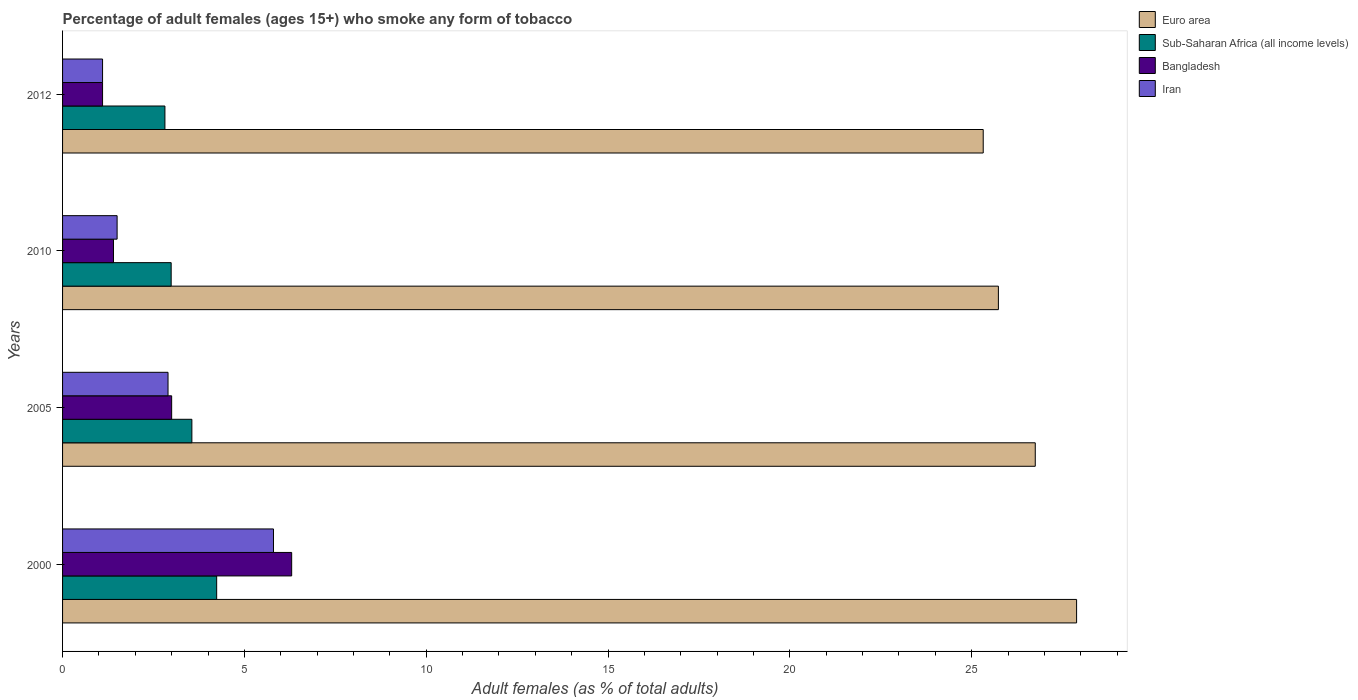Are the number of bars per tick equal to the number of legend labels?
Keep it short and to the point. Yes. Are the number of bars on each tick of the Y-axis equal?
Make the answer very short. Yes. In how many cases, is the number of bars for a given year not equal to the number of legend labels?
Provide a succinct answer. 0. What is the percentage of adult females who smoke in Sub-Saharan Africa (all income levels) in 2000?
Your answer should be very brief. 4.24. Across all years, what is the maximum percentage of adult females who smoke in Bangladesh?
Provide a succinct answer. 6.3. Across all years, what is the minimum percentage of adult females who smoke in Bangladesh?
Ensure brevity in your answer.  1.1. In which year was the percentage of adult females who smoke in Euro area minimum?
Your response must be concise. 2012. What is the total percentage of adult females who smoke in Bangladesh in the graph?
Keep it short and to the point. 11.8. What is the difference between the percentage of adult females who smoke in Iran in 2005 and that in 2010?
Your response must be concise. 1.4. What is the difference between the percentage of adult females who smoke in Sub-Saharan Africa (all income levels) in 2010 and the percentage of adult females who smoke in Euro area in 2005?
Provide a short and direct response. -23.76. What is the average percentage of adult females who smoke in Euro area per year?
Offer a terse response. 26.42. In the year 2012, what is the difference between the percentage of adult females who smoke in Iran and percentage of adult females who smoke in Euro area?
Give a very brief answer. -24.22. What is the ratio of the percentage of adult females who smoke in Bangladesh in 2010 to that in 2012?
Provide a succinct answer. 1.27. Is the difference between the percentage of adult females who smoke in Iran in 2010 and 2012 greater than the difference between the percentage of adult females who smoke in Euro area in 2010 and 2012?
Keep it short and to the point. No. What is the difference between the highest and the lowest percentage of adult females who smoke in Bangladesh?
Keep it short and to the point. 5.2. In how many years, is the percentage of adult females who smoke in Iran greater than the average percentage of adult females who smoke in Iran taken over all years?
Offer a terse response. 2. Is the sum of the percentage of adult females who smoke in Euro area in 2000 and 2005 greater than the maximum percentage of adult females who smoke in Bangladesh across all years?
Give a very brief answer. Yes. What does the 1st bar from the top in 2010 represents?
Your answer should be compact. Iran. What does the 2nd bar from the bottom in 2012 represents?
Provide a short and direct response. Sub-Saharan Africa (all income levels). What is the difference between two consecutive major ticks on the X-axis?
Your answer should be very brief. 5. Does the graph contain any zero values?
Provide a succinct answer. No. What is the title of the graph?
Offer a terse response. Percentage of adult females (ages 15+) who smoke any form of tobacco. What is the label or title of the X-axis?
Your answer should be compact. Adult females (as % of total adults). What is the label or title of the Y-axis?
Ensure brevity in your answer.  Years. What is the Adult females (as % of total adults) of Euro area in 2000?
Your answer should be compact. 27.88. What is the Adult females (as % of total adults) of Sub-Saharan Africa (all income levels) in 2000?
Offer a very short reply. 4.24. What is the Adult females (as % of total adults) of Bangladesh in 2000?
Your answer should be compact. 6.3. What is the Adult females (as % of total adults) in Iran in 2000?
Provide a succinct answer. 5.8. What is the Adult females (as % of total adults) in Euro area in 2005?
Provide a short and direct response. 26.75. What is the Adult females (as % of total adults) in Sub-Saharan Africa (all income levels) in 2005?
Offer a terse response. 3.56. What is the Adult females (as % of total adults) of Iran in 2005?
Keep it short and to the point. 2.9. What is the Adult females (as % of total adults) of Euro area in 2010?
Your response must be concise. 25.73. What is the Adult females (as % of total adults) of Sub-Saharan Africa (all income levels) in 2010?
Your answer should be compact. 2.99. What is the Adult females (as % of total adults) in Iran in 2010?
Your answer should be compact. 1.5. What is the Adult females (as % of total adults) of Euro area in 2012?
Your answer should be compact. 25.32. What is the Adult females (as % of total adults) in Sub-Saharan Africa (all income levels) in 2012?
Your answer should be very brief. 2.81. Across all years, what is the maximum Adult females (as % of total adults) of Euro area?
Ensure brevity in your answer.  27.88. Across all years, what is the maximum Adult females (as % of total adults) of Sub-Saharan Africa (all income levels)?
Offer a terse response. 4.24. Across all years, what is the maximum Adult females (as % of total adults) in Iran?
Provide a succinct answer. 5.8. Across all years, what is the minimum Adult females (as % of total adults) in Euro area?
Provide a succinct answer. 25.32. Across all years, what is the minimum Adult females (as % of total adults) in Sub-Saharan Africa (all income levels)?
Keep it short and to the point. 2.81. Across all years, what is the minimum Adult females (as % of total adults) in Bangladesh?
Your answer should be compact. 1.1. Across all years, what is the minimum Adult females (as % of total adults) in Iran?
Make the answer very short. 1.1. What is the total Adult females (as % of total adults) in Euro area in the graph?
Your answer should be very brief. 105.68. What is the total Adult females (as % of total adults) in Sub-Saharan Africa (all income levels) in the graph?
Keep it short and to the point. 13.59. What is the total Adult females (as % of total adults) in Bangladesh in the graph?
Ensure brevity in your answer.  11.8. What is the total Adult females (as % of total adults) in Iran in the graph?
Provide a succinct answer. 11.3. What is the difference between the Adult females (as % of total adults) in Euro area in 2000 and that in 2005?
Provide a succinct answer. 1.14. What is the difference between the Adult females (as % of total adults) in Sub-Saharan Africa (all income levels) in 2000 and that in 2005?
Offer a very short reply. 0.68. What is the difference between the Adult females (as % of total adults) in Iran in 2000 and that in 2005?
Your answer should be very brief. 2.9. What is the difference between the Adult females (as % of total adults) of Euro area in 2000 and that in 2010?
Make the answer very short. 2.15. What is the difference between the Adult females (as % of total adults) in Sub-Saharan Africa (all income levels) in 2000 and that in 2010?
Give a very brief answer. 1.25. What is the difference between the Adult females (as % of total adults) in Iran in 2000 and that in 2010?
Provide a succinct answer. 4.3. What is the difference between the Adult females (as % of total adults) in Euro area in 2000 and that in 2012?
Your answer should be very brief. 2.57. What is the difference between the Adult females (as % of total adults) of Sub-Saharan Africa (all income levels) in 2000 and that in 2012?
Offer a terse response. 1.42. What is the difference between the Adult females (as % of total adults) in Euro area in 2005 and that in 2010?
Your response must be concise. 1.01. What is the difference between the Adult females (as % of total adults) in Sub-Saharan Africa (all income levels) in 2005 and that in 2010?
Provide a short and direct response. 0.57. What is the difference between the Adult females (as % of total adults) of Iran in 2005 and that in 2010?
Your answer should be compact. 1.4. What is the difference between the Adult females (as % of total adults) of Euro area in 2005 and that in 2012?
Provide a succinct answer. 1.43. What is the difference between the Adult females (as % of total adults) in Sub-Saharan Africa (all income levels) in 2005 and that in 2012?
Offer a very short reply. 0.74. What is the difference between the Adult females (as % of total adults) in Iran in 2005 and that in 2012?
Offer a terse response. 1.8. What is the difference between the Adult females (as % of total adults) in Euro area in 2010 and that in 2012?
Your answer should be compact. 0.42. What is the difference between the Adult females (as % of total adults) in Sub-Saharan Africa (all income levels) in 2010 and that in 2012?
Give a very brief answer. 0.17. What is the difference between the Adult females (as % of total adults) of Bangladesh in 2010 and that in 2012?
Offer a terse response. 0.3. What is the difference between the Adult females (as % of total adults) of Iran in 2010 and that in 2012?
Your answer should be compact. 0.4. What is the difference between the Adult females (as % of total adults) of Euro area in 2000 and the Adult females (as % of total adults) of Sub-Saharan Africa (all income levels) in 2005?
Keep it short and to the point. 24.33. What is the difference between the Adult females (as % of total adults) of Euro area in 2000 and the Adult females (as % of total adults) of Bangladesh in 2005?
Provide a short and direct response. 24.88. What is the difference between the Adult females (as % of total adults) of Euro area in 2000 and the Adult females (as % of total adults) of Iran in 2005?
Offer a terse response. 24.98. What is the difference between the Adult females (as % of total adults) in Sub-Saharan Africa (all income levels) in 2000 and the Adult females (as % of total adults) in Bangladesh in 2005?
Provide a succinct answer. 1.24. What is the difference between the Adult females (as % of total adults) of Sub-Saharan Africa (all income levels) in 2000 and the Adult females (as % of total adults) of Iran in 2005?
Offer a terse response. 1.34. What is the difference between the Adult females (as % of total adults) in Bangladesh in 2000 and the Adult females (as % of total adults) in Iran in 2005?
Offer a terse response. 3.4. What is the difference between the Adult females (as % of total adults) of Euro area in 2000 and the Adult females (as % of total adults) of Sub-Saharan Africa (all income levels) in 2010?
Make the answer very short. 24.9. What is the difference between the Adult females (as % of total adults) in Euro area in 2000 and the Adult females (as % of total adults) in Bangladesh in 2010?
Provide a succinct answer. 26.48. What is the difference between the Adult females (as % of total adults) of Euro area in 2000 and the Adult females (as % of total adults) of Iran in 2010?
Make the answer very short. 26.38. What is the difference between the Adult females (as % of total adults) in Sub-Saharan Africa (all income levels) in 2000 and the Adult females (as % of total adults) in Bangladesh in 2010?
Offer a very short reply. 2.84. What is the difference between the Adult females (as % of total adults) of Sub-Saharan Africa (all income levels) in 2000 and the Adult females (as % of total adults) of Iran in 2010?
Give a very brief answer. 2.74. What is the difference between the Adult females (as % of total adults) of Euro area in 2000 and the Adult females (as % of total adults) of Sub-Saharan Africa (all income levels) in 2012?
Your answer should be compact. 25.07. What is the difference between the Adult females (as % of total adults) of Euro area in 2000 and the Adult females (as % of total adults) of Bangladesh in 2012?
Offer a very short reply. 26.78. What is the difference between the Adult females (as % of total adults) in Euro area in 2000 and the Adult females (as % of total adults) in Iran in 2012?
Ensure brevity in your answer.  26.78. What is the difference between the Adult females (as % of total adults) in Sub-Saharan Africa (all income levels) in 2000 and the Adult females (as % of total adults) in Bangladesh in 2012?
Provide a short and direct response. 3.14. What is the difference between the Adult females (as % of total adults) in Sub-Saharan Africa (all income levels) in 2000 and the Adult females (as % of total adults) in Iran in 2012?
Offer a very short reply. 3.14. What is the difference between the Adult females (as % of total adults) of Euro area in 2005 and the Adult females (as % of total adults) of Sub-Saharan Africa (all income levels) in 2010?
Your answer should be very brief. 23.76. What is the difference between the Adult females (as % of total adults) in Euro area in 2005 and the Adult females (as % of total adults) in Bangladesh in 2010?
Keep it short and to the point. 25.35. What is the difference between the Adult females (as % of total adults) of Euro area in 2005 and the Adult females (as % of total adults) of Iran in 2010?
Keep it short and to the point. 25.25. What is the difference between the Adult females (as % of total adults) in Sub-Saharan Africa (all income levels) in 2005 and the Adult females (as % of total adults) in Bangladesh in 2010?
Offer a terse response. 2.16. What is the difference between the Adult females (as % of total adults) of Sub-Saharan Africa (all income levels) in 2005 and the Adult females (as % of total adults) of Iran in 2010?
Your answer should be compact. 2.06. What is the difference between the Adult females (as % of total adults) in Bangladesh in 2005 and the Adult females (as % of total adults) in Iran in 2010?
Offer a terse response. 1.5. What is the difference between the Adult females (as % of total adults) of Euro area in 2005 and the Adult females (as % of total adults) of Sub-Saharan Africa (all income levels) in 2012?
Provide a short and direct response. 23.93. What is the difference between the Adult females (as % of total adults) of Euro area in 2005 and the Adult females (as % of total adults) of Bangladesh in 2012?
Your answer should be very brief. 25.65. What is the difference between the Adult females (as % of total adults) in Euro area in 2005 and the Adult females (as % of total adults) in Iran in 2012?
Offer a very short reply. 25.65. What is the difference between the Adult females (as % of total adults) in Sub-Saharan Africa (all income levels) in 2005 and the Adult females (as % of total adults) in Bangladesh in 2012?
Keep it short and to the point. 2.46. What is the difference between the Adult females (as % of total adults) in Sub-Saharan Africa (all income levels) in 2005 and the Adult females (as % of total adults) in Iran in 2012?
Your answer should be very brief. 2.46. What is the difference between the Adult females (as % of total adults) of Bangladesh in 2005 and the Adult females (as % of total adults) of Iran in 2012?
Your answer should be compact. 1.9. What is the difference between the Adult females (as % of total adults) of Euro area in 2010 and the Adult females (as % of total adults) of Sub-Saharan Africa (all income levels) in 2012?
Your answer should be compact. 22.92. What is the difference between the Adult females (as % of total adults) in Euro area in 2010 and the Adult females (as % of total adults) in Bangladesh in 2012?
Offer a terse response. 24.63. What is the difference between the Adult females (as % of total adults) of Euro area in 2010 and the Adult females (as % of total adults) of Iran in 2012?
Offer a very short reply. 24.63. What is the difference between the Adult females (as % of total adults) in Sub-Saharan Africa (all income levels) in 2010 and the Adult females (as % of total adults) in Bangladesh in 2012?
Provide a short and direct response. 1.89. What is the difference between the Adult females (as % of total adults) in Sub-Saharan Africa (all income levels) in 2010 and the Adult females (as % of total adults) in Iran in 2012?
Give a very brief answer. 1.89. What is the difference between the Adult females (as % of total adults) of Bangladesh in 2010 and the Adult females (as % of total adults) of Iran in 2012?
Provide a succinct answer. 0.3. What is the average Adult females (as % of total adults) of Euro area per year?
Offer a very short reply. 26.42. What is the average Adult females (as % of total adults) of Sub-Saharan Africa (all income levels) per year?
Keep it short and to the point. 3.4. What is the average Adult females (as % of total adults) in Bangladesh per year?
Your answer should be very brief. 2.95. What is the average Adult females (as % of total adults) in Iran per year?
Provide a succinct answer. 2.83. In the year 2000, what is the difference between the Adult females (as % of total adults) in Euro area and Adult females (as % of total adults) in Sub-Saharan Africa (all income levels)?
Offer a terse response. 23.65. In the year 2000, what is the difference between the Adult females (as % of total adults) in Euro area and Adult females (as % of total adults) in Bangladesh?
Provide a short and direct response. 21.58. In the year 2000, what is the difference between the Adult females (as % of total adults) in Euro area and Adult females (as % of total adults) in Iran?
Your answer should be compact. 22.08. In the year 2000, what is the difference between the Adult females (as % of total adults) of Sub-Saharan Africa (all income levels) and Adult females (as % of total adults) of Bangladesh?
Offer a very short reply. -2.06. In the year 2000, what is the difference between the Adult females (as % of total adults) in Sub-Saharan Africa (all income levels) and Adult females (as % of total adults) in Iran?
Ensure brevity in your answer.  -1.56. In the year 2005, what is the difference between the Adult females (as % of total adults) in Euro area and Adult females (as % of total adults) in Sub-Saharan Africa (all income levels)?
Make the answer very short. 23.19. In the year 2005, what is the difference between the Adult females (as % of total adults) in Euro area and Adult females (as % of total adults) in Bangladesh?
Offer a very short reply. 23.75. In the year 2005, what is the difference between the Adult females (as % of total adults) in Euro area and Adult females (as % of total adults) in Iran?
Your answer should be very brief. 23.85. In the year 2005, what is the difference between the Adult females (as % of total adults) of Sub-Saharan Africa (all income levels) and Adult females (as % of total adults) of Bangladesh?
Offer a terse response. 0.56. In the year 2005, what is the difference between the Adult females (as % of total adults) in Sub-Saharan Africa (all income levels) and Adult females (as % of total adults) in Iran?
Ensure brevity in your answer.  0.66. In the year 2010, what is the difference between the Adult females (as % of total adults) of Euro area and Adult females (as % of total adults) of Sub-Saharan Africa (all income levels)?
Offer a very short reply. 22.75. In the year 2010, what is the difference between the Adult females (as % of total adults) of Euro area and Adult females (as % of total adults) of Bangladesh?
Your answer should be compact. 24.33. In the year 2010, what is the difference between the Adult females (as % of total adults) in Euro area and Adult females (as % of total adults) in Iran?
Keep it short and to the point. 24.23. In the year 2010, what is the difference between the Adult females (as % of total adults) in Sub-Saharan Africa (all income levels) and Adult females (as % of total adults) in Bangladesh?
Your answer should be compact. 1.59. In the year 2010, what is the difference between the Adult females (as % of total adults) of Sub-Saharan Africa (all income levels) and Adult females (as % of total adults) of Iran?
Your answer should be very brief. 1.49. In the year 2012, what is the difference between the Adult females (as % of total adults) in Euro area and Adult females (as % of total adults) in Sub-Saharan Africa (all income levels)?
Make the answer very short. 22.5. In the year 2012, what is the difference between the Adult females (as % of total adults) of Euro area and Adult females (as % of total adults) of Bangladesh?
Provide a short and direct response. 24.22. In the year 2012, what is the difference between the Adult females (as % of total adults) in Euro area and Adult females (as % of total adults) in Iran?
Provide a succinct answer. 24.22. In the year 2012, what is the difference between the Adult females (as % of total adults) of Sub-Saharan Africa (all income levels) and Adult females (as % of total adults) of Bangladesh?
Provide a succinct answer. 1.71. In the year 2012, what is the difference between the Adult females (as % of total adults) of Sub-Saharan Africa (all income levels) and Adult females (as % of total adults) of Iran?
Provide a short and direct response. 1.71. In the year 2012, what is the difference between the Adult females (as % of total adults) in Bangladesh and Adult females (as % of total adults) in Iran?
Your answer should be very brief. 0. What is the ratio of the Adult females (as % of total adults) in Euro area in 2000 to that in 2005?
Make the answer very short. 1.04. What is the ratio of the Adult females (as % of total adults) in Sub-Saharan Africa (all income levels) in 2000 to that in 2005?
Provide a succinct answer. 1.19. What is the ratio of the Adult females (as % of total adults) of Euro area in 2000 to that in 2010?
Keep it short and to the point. 1.08. What is the ratio of the Adult females (as % of total adults) in Sub-Saharan Africa (all income levels) in 2000 to that in 2010?
Provide a succinct answer. 1.42. What is the ratio of the Adult females (as % of total adults) of Iran in 2000 to that in 2010?
Make the answer very short. 3.87. What is the ratio of the Adult females (as % of total adults) of Euro area in 2000 to that in 2012?
Provide a short and direct response. 1.1. What is the ratio of the Adult females (as % of total adults) in Sub-Saharan Africa (all income levels) in 2000 to that in 2012?
Make the answer very short. 1.51. What is the ratio of the Adult females (as % of total adults) of Bangladesh in 2000 to that in 2012?
Offer a very short reply. 5.73. What is the ratio of the Adult females (as % of total adults) in Iran in 2000 to that in 2012?
Give a very brief answer. 5.27. What is the ratio of the Adult females (as % of total adults) in Euro area in 2005 to that in 2010?
Your answer should be very brief. 1.04. What is the ratio of the Adult females (as % of total adults) in Sub-Saharan Africa (all income levels) in 2005 to that in 2010?
Provide a short and direct response. 1.19. What is the ratio of the Adult females (as % of total adults) in Bangladesh in 2005 to that in 2010?
Offer a very short reply. 2.14. What is the ratio of the Adult females (as % of total adults) in Iran in 2005 to that in 2010?
Your response must be concise. 1.93. What is the ratio of the Adult females (as % of total adults) in Euro area in 2005 to that in 2012?
Your response must be concise. 1.06. What is the ratio of the Adult females (as % of total adults) of Sub-Saharan Africa (all income levels) in 2005 to that in 2012?
Give a very brief answer. 1.26. What is the ratio of the Adult females (as % of total adults) of Bangladesh in 2005 to that in 2012?
Your answer should be compact. 2.73. What is the ratio of the Adult females (as % of total adults) in Iran in 2005 to that in 2012?
Offer a terse response. 2.64. What is the ratio of the Adult females (as % of total adults) in Euro area in 2010 to that in 2012?
Provide a short and direct response. 1.02. What is the ratio of the Adult females (as % of total adults) of Sub-Saharan Africa (all income levels) in 2010 to that in 2012?
Your response must be concise. 1.06. What is the ratio of the Adult females (as % of total adults) in Bangladesh in 2010 to that in 2012?
Offer a very short reply. 1.27. What is the ratio of the Adult females (as % of total adults) of Iran in 2010 to that in 2012?
Make the answer very short. 1.36. What is the difference between the highest and the second highest Adult females (as % of total adults) in Euro area?
Give a very brief answer. 1.14. What is the difference between the highest and the second highest Adult females (as % of total adults) of Sub-Saharan Africa (all income levels)?
Provide a succinct answer. 0.68. What is the difference between the highest and the second highest Adult females (as % of total adults) in Iran?
Provide a short and direct response. 2.9. What is the difference between the highest and the lowest Adult females (as % of total adults) in Euro area?
Offer a terse response. 2.57. What is the difference between the highest and the lowest Adult females (as % of total adults) in Sub-Saharan Africa (all income levels)?
Make the answer very short. 1.42. What is the difference between the highest and the lowest Adult females (as % of total adults) of Iran?
Your answer should be very brief. 4.7. 